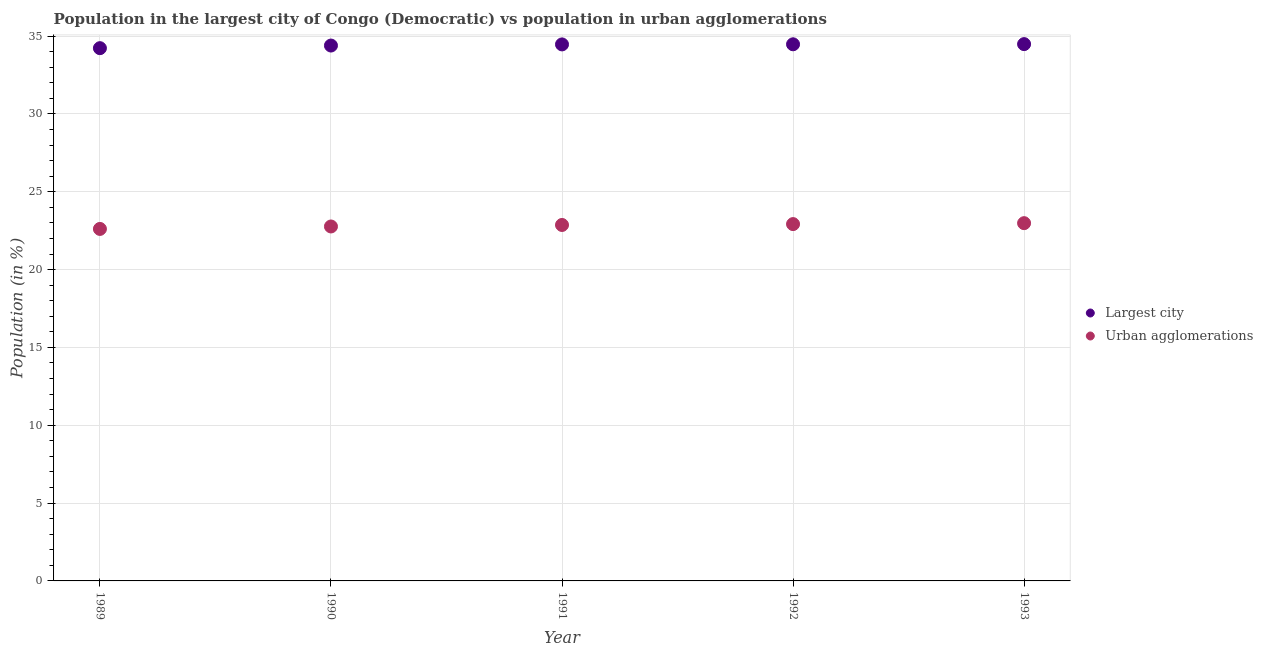How many different coloured dotlines are there?
Your answer should be very brief. 2. Is the number of dotlines equal to the number of legend labels?
Your answer should be very brief. Yes. What is the population in the largest city in 1989?
Your response must be concise. 34.22. Across all years, what is the maximum population in urban agglomerations?
Provide a succinct answer. 22.98. Across all years, what is the minimum population in urban agglomerations?
Give a very brief answer. 22.61. In which year was the population in urban agglomerations minimum?
Your answer should be very brief. 1989. What is the total population in urban agglomerations in the graph?
Provide a succinct answer. 114.15. What is the difference between the population in the largest city in 1991 and that in 1993?
Your answer should be compact. -0.02. What is the difference between the population in the largest city in 1991 and the population in urban agglomerations in 1992?
Provide a succinct answer. 11.54. What is the average population in the largest city per year?
Offer a terse response. 34.41. In the year 1993, what is the difference between the population in the largest city and population in urban agglomerations?
Ensure brevity in your answer.  11.5. What is the ratio of the population in urban agglomerations in 1991 to that in 1992?
Your answer should be compact. 1. What is the difference between the highest and the second highest population in urban agglomerations?
Offer a terse response. 0.06. What is the difference between the highest and the lowest population in urban agglomerations?
Provide a short and direct response. 0.37. In how many years, is the population in urban agglomerations greater than the average population in urban agglomerations taken over all years?
Give a very brief answer. 3. Is the sum of the population in the largest city in 1989 and 1992 greater than the maximum population in urban agglomerations across all years?
Offer a very short reply. Yes. Is the population in urban agglomerations strictly greater than the population in the largest city over the years?
Make the answer very short. No. How many dotlines are there?
Offer a terse response. 2. What is the difference between two consecutive major ticks on the Y-axis?
Your answer should be very brief. 5. Are the values on the major ticks of Y-axis written in scientific E-notation?
Provide a succinct answer. No. Does the graph contain any zero values?
Offer a very short reply. No. Does the graph contain grids?
Provide a short and direct response. Yes. Where does the legend appear in the graph?
Keep it short and to the point. Center right. What is the title of the graph?
Your response must be concise. Population in the largest city of Congo (Democratic) vs population in urban agglomerations. Does "Drinking water services" appear as one of the legend labels in the graph?
Make the answer very short. No. What is the label or title of the X-axis?
Offer a very short reply. Year. What is the label or title of the Y-axis?
Ensure brevity in your answer.  Population (in %). What is the Population (in %) in Largest city in 1989?
Offer a terse response. 34.22. What is the Population (in %) of Urban agglomerations in 1989?
Provide a succinct answer. 22.61. What is the Population (in %) in Largest city in 1990?
Provide a succinct answer. 34.39. What is the Population (in %) in Urban agglomerations in 1990?
Your answer should be very brief. 22.77. What is the Population (in %) in Largest city in 1991?
Make the answer very short. 34.46. What is the Population (in %) of Urban agglomerations in 1991?
Provide a succinct answer. 22.87. What is the Population (in %) of Largest city in 1992?
Provide a short and direct response. 34.47. What is the Population (in %) of Urban agglomerations in 1992?
Provide a succinct answer. 22.92. What is the Population (in %) in Largest city in 1993?
Ensure brevity in your answer.  34.48. What is the Population (in %) in Urban agglomerations in 1993?
Give a very brief answer. 22.98. Across all years, what is the maximum Population (in %) of Largest city?
Offer a terse response. 34.48. Across all years, what is the maximum Population (in %) of Urban agglomerations?
Your answer should be compact. 22.98. Across all years, what is the minimum Population (in %) in Largest city?
Your response must be concise. 34.22. Across all years, what is the minimum Population (in %) of Urban agglomerations?
Offer a very short reply. 22.61. What is the total Population (in %) of Largest city in the graph?
Ensure brevity in your answer.  172.03. What is the total Population (in %) of Urban agglomerations in the graph?
Offer a terse response. 114.15. What is the difference between the Population (in %) of Largest city in 1989 and that in 1990?
Your response must be concise. -0.17. What is the difference between the Population (in %) of Urban agglomerations in 1989 and that in 1990?
Make the answer very short. -0.16. What is the difference between the Population (in %) in Largest city in 1989 and that in 1991?
Provide a succinct answer. -0.24. What is the difference between the Population (in %) of Urban agglomerations in 1989 and that in 1991?
Provide a short and direct response. -0.25. What is the difference between the Population (in %) in Largest city in 1989 and that in 1992?
Ensure brevity in your answer.  -0.25. What is the difference between the Population (in %) of Urban agglomerations in 1989 and that in 1992?
Offer a terse response. -0.31. What is the difference between the Population (in %) in Largest city in 1989 and that in 1993?
Offer a very short reply. -0.26. What is the difference between the Population (in %) in Urban agglomerations in 1989 and that in 1993?
Keep it short and to the point. -0.37. What is the difference between the Population (in %) in Largest city in 1990 and that in 1991?
Make the answer very short. -0.07. What is the difference between the Population (in %) in Urban agglomerations in 1990 and that in 1991?
Ensure brevity in your answer.  -0.1. What is the difference between the Population (in %) of Largest city in 1990 and that in 1992?
Ensure brevity in your answer.  -0.08. What is the difference between the Population (in %) in Urban agglomerations in 1990 and that in 1992?
Offer a terse response. -0.15. What is the difference between the Population (in %) of Largest city in 1990 and that in 1993?
Ensure brevity in your answer.  -0.09. What is the difference between the Population (in %) in Urban agglomerations in 1990 and that in 1993?
Your response must be concise. -0.21. What is the difference between the Population (in %) in Largest city in 1991 and that in 1992?
Ensure brevity in your answer.  -0.01. What is the difference between the Population (in %) of Urban agglomerations in 1991 and that in 1992?
Keep it short and to the point. -0.06. What is the difference between the Population (in %) of Largest city in 1991 and that in 1993?
Your response must be concise. -0.02. What is the difference between the Population (in %) of Urban agglomerations in 1991 and that in 1993?
Your answer should be very brief. -0.12. What is the difference between the Population (in %) of Largest city in 1992 and that in 1993?
Offer a terse response. -0.01. What is the difference between the Population (in %) of Urban agglomerations in 1992 and that in 1993?
Give a very brief answer. -0.06. What is the difference between the Population (in %) in Largest city in 1989 and the Population (in %) in Urban agglomerations in 1990?
Provide a short and direct response. 11.45. What is the difference between the Population (in %) in Largest city in 1989 and the Population (in %) in Urban agglomerations in 1991?
Offer a terse response. 11.36. What is the difference between the Population (in %) of Largest city in 1989 and the Population (in %) of Urban agglomerations in 1992?
Make the answer very short. 11.3. What is the difference between the Population (in %) of Largest city in 1989 and the Population (in %) of Urban agglomerations in 1993?
Your answer should be compact. 11.24. What is the difference between the Population (in %) of Largest city in 1990 and the Population (in %) of Urban agglomerations in 1991?
Your response must be concise. 11.53. What is the difference between the Population (in %) in Largest city in 1990 and the Population (in %) in Urban agglomerations in 1992?
Your response must be concise. 11.47. What is the difference between the Population (in %) in Largest city in 1990 and the Population (in %) in Urban agglomerations in 1993?
Your response must be concise. 11.41. What is the difference between the Population (in %) of Largest city in 1991 and the Population (in %) of Urban agglomerations in 1992?
Make the answer very short. 11.54. What is the difference between the Population (in %) of Largest city in 1991 and the Population (in %) of Urban agglomerations in 1993?
Ensure brevity in your answer.  11.48. What is the difference between the Population (in %) of Largest city in 1992 and the Population (in %) of Urban agglomerations in 1993?
Provide a succinct answer. 11.49. What is the average Population (in %) in Largest city per year?
Your answer should be compact. 34.41. What is the average Population (in %) of Urban agglomerations per year?
Make the answer very short. 22.83. In the year 1989, what is the difference between the Population (in %) of Largest city and Population (in %) of Urban agglomerations?
Your response must be concise. 11.61. In the year 1990, what is the difference between the Population (in %) of Largest city and Population (in %) of Urban agglomerations?
Your answer should be compact. 11.62. In the year 1991, what is the difference between the Population (in %) of Largest city and Population (in %) of Urban agglomerations?
Offer a very short reply. 11.6. In the year 1992, what is the difference between the Population (in %) of Largest city and Population (in %) of Urban agglomerations?
Your response must be concise. 11.55. In the year 1993, what is the difference between the Population (in %) of Largest city and Population (in %) of Urban agglomerations?
Offer a terse response. 11.5. What is the ratio of the Population (in %) in Largest city in 1989 to that in 1991?
Offer a terse response. 0.99. What is the ratio of the Population (in %) in Urban agglomerations in 1989 to that in 1991?
Your response must be concise. 0.99. What is the ratio of the Population (in %) in Largest city in 1989 to that in 1992?
Your answer should be very brief. 0.99. What is the ratio of the Population (in %) of Urban agglomerations in 1989 to that in 1992?
Ensure brevity in your answer.  0.99. What is the ratio of the Population (in %) in Urban agglomerations in 1989 to that in 1993?
Offer a terse response. 0.98. What is the ratio of the Population (in %) of Urban agglomerations in 1990 to that in 1991?
Make the answer very short. 1. What is the ratio of the Population (in %) in Largest city in 1990 to that in 1993?
Give a very brief answer. 1. What is the ratio of the Population (in %) in Urban agglomerations in 1990 to that in 1993?
Your response must be concise. 0.99. What is the ratio of the Population (in %) in Urban agglomerations in 1991 to that in 1992?
Provide a short and direct response. 1. What is the ratio of the Population (in %) of Largest city in 1991 to that in 1993?
Offer a terse response. 1. What is the ratio of the Population (in %) of Urban agglomerations in 1991 to that in 1993?
Keep it short and to the point. 0.99. What is the difference between the highest and the second highest Population (in %) in Largest city?
Your response must be concise. 0.01. What is the difference between the highest and the second highest Population (in %) of Urban agglomerations?
Make the answer very short. 0.06. What is the difference between the highest and the lowest Population (in %) of Largest city?
Make the answer very short. 0.26. What is the difference between the highest and the lowest Population (in %) of Urban agglomerations?
Ensure brevity in your answer.  0.37. 